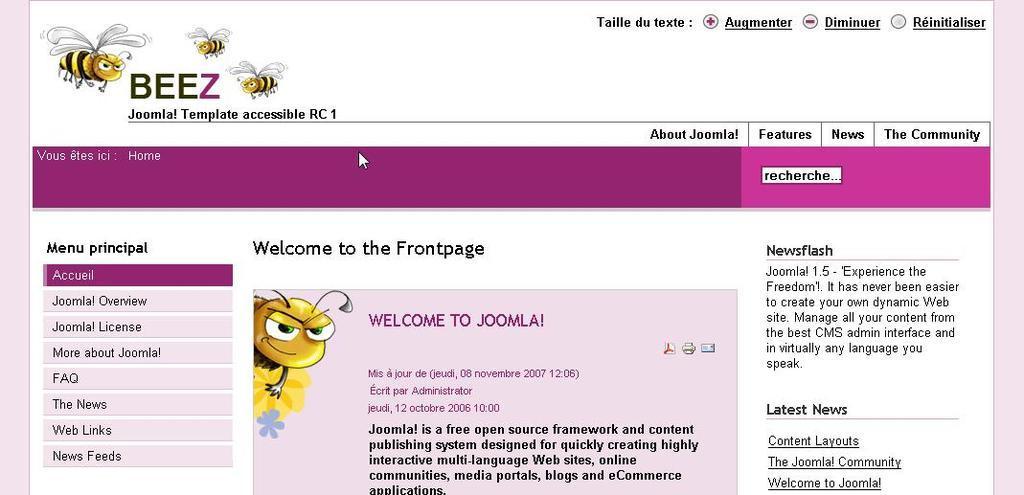How would you summarize this image in a sentence or two? This image consists of a screenshot of a monitor screen. In this image I can see the text and few cartoon images of bees. 